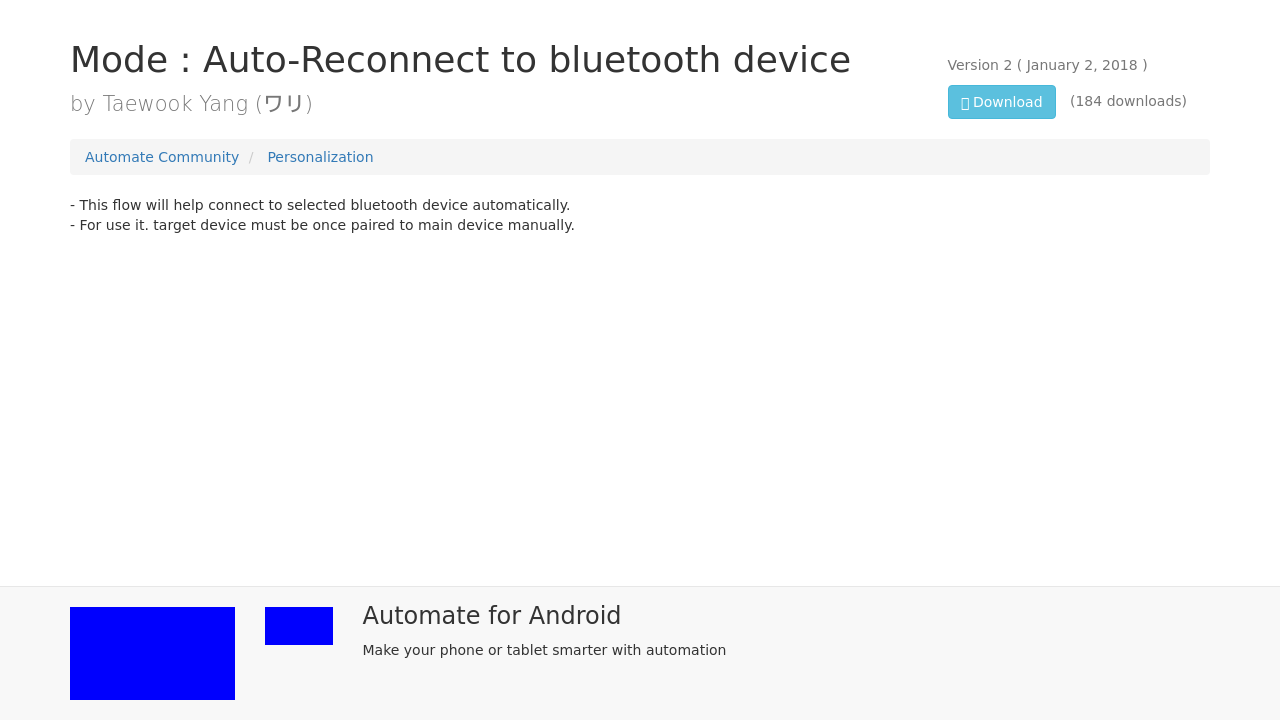What's the procedure for constructing this website from scratch with HTML? To construct a website like the one shown in the image from scratch using HTML, begin by defining the DOCTYPE and creating an html element. Inside, include head and body sections. The head should contain meta tags for proper display on various devices, links to CSS files for styling, and the title of your site. The body will house the content, divided into elements like headers, paragraphs, links, images, and more, organized meaningfully, often with the aid of division (div) elements. Utilize CSS for visual styling and possibly JavaScript for interactive features. 